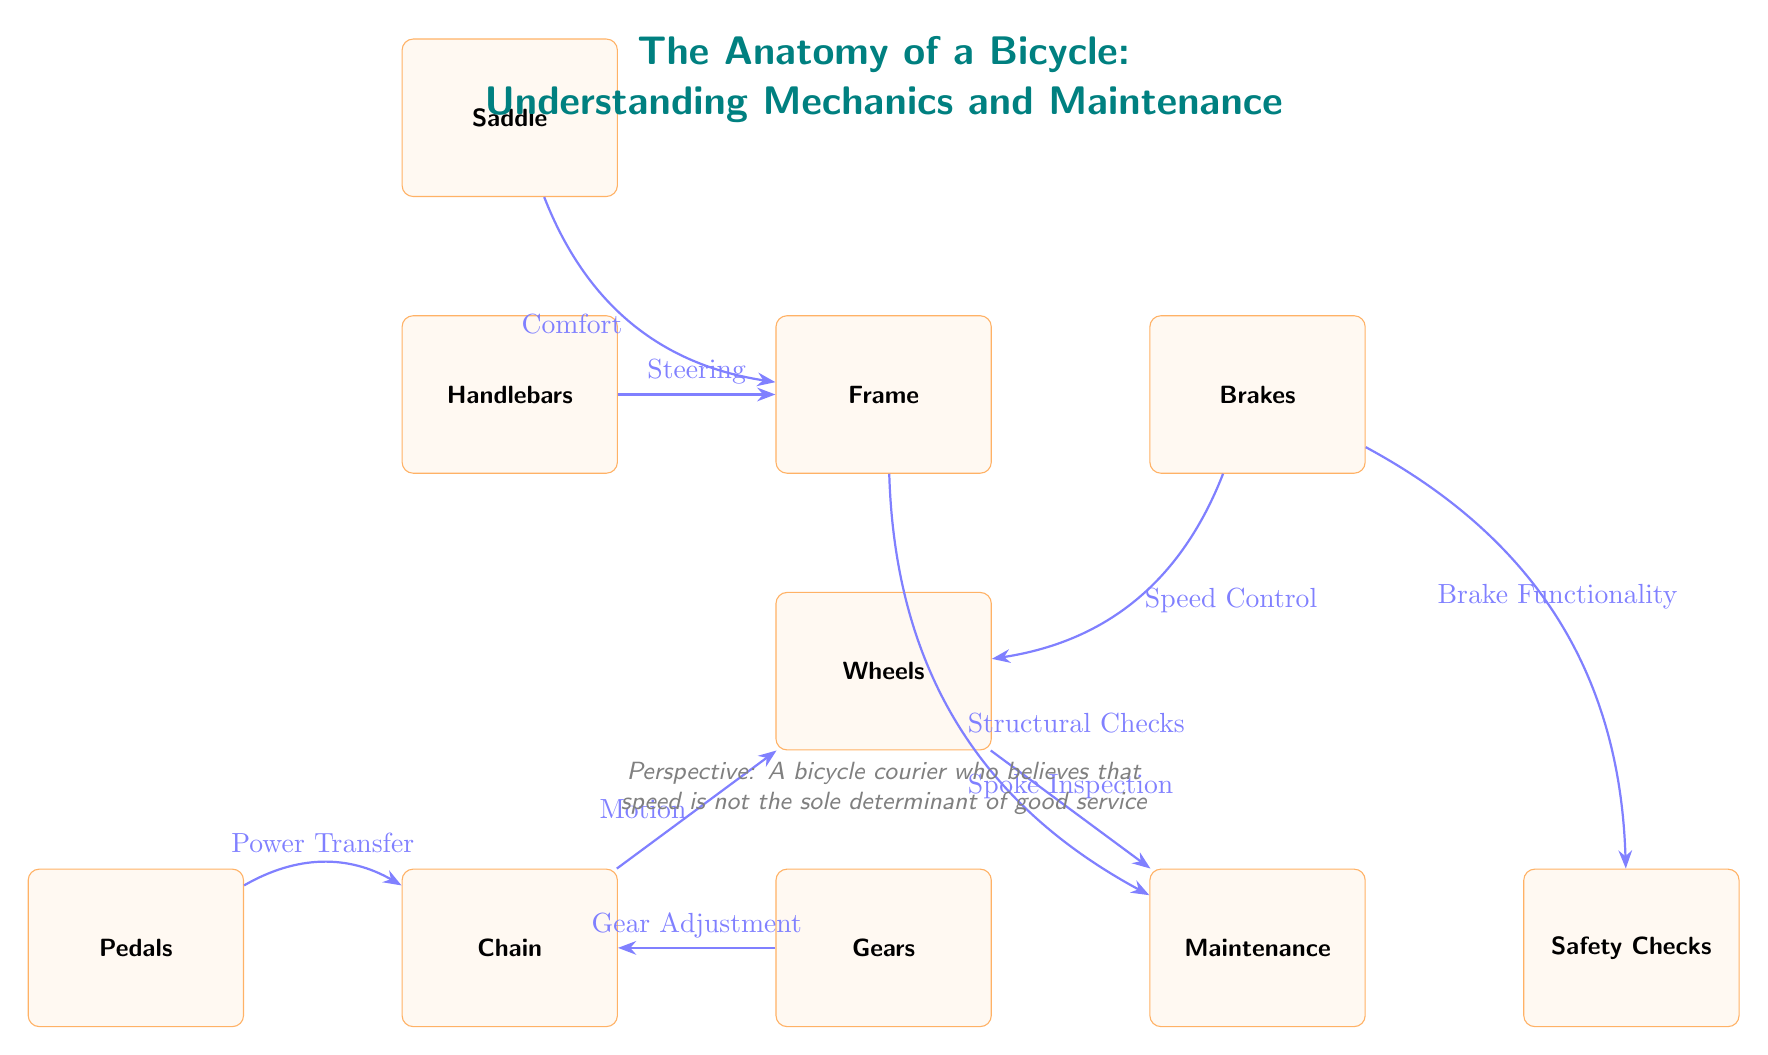What is the main structure of a bicycle? The main structure of a bicycle is represented by the node labeled "Frame." This node is centrally located and connects to other parts, indicating it is the foundational element of the bicycle's anatomy.
Answer: Frame How many components are directly connected to the frame? The frame node is connected to four components: handlebars, brakes, saddle, and maintenance. Thus, by counting the connections, we find that there are four direct components linked to the frame.
Answer: Four What is the function of the chain in a bicycle? The chain connects the pedals and wheels, serving the function of motion transfer from the power generated by the pedals to the rotation of the wheels. This illustrates its critical role in the drivetrain of the bicycle.
Answer: Motion What is the relationship between the brakes and the wheels? The diagram indicates that brakes provide speed control to the wheels. This means when the brakes are applied, they affect the movement and speed of the wheels directly.
Answer: Speed Control Which component is responsible for comfort in riding? According to the diagram, the component that contributes to comfort in riding is the saddle, which connects to the frame and is highlighted as a key part of the bicycle's anatomy for rider comfort.
Answer: Saddle How does gear adjustment relate to the chain? The gears adjust the tension and speed capability of the chain. This relationship is crucial because gear changes affect how effectively the chain transfers power to the wheels, which can influence overall cycling performance.
Answer: Gear Adjustment What action is indicated by the spokes of the wheels? The diagram shows that spokes are subject to inspection, implying that their maintenance is necessary to ensure the structural integrity and safety of the wheels during cycling.
Answer: Spoke Inspection What type of checks are necessary for the frame? The diagram emphasizes that structural checks are necessary for the frame. This is important to ensure that the frame remains safe and functional over time, preventing potential failures.
Answer: Structural Checks Which part of the bicycle helps in steering? The handlebars are identified in the diagram as the component that provides steering control. This underscores their vital role in navigating and maneuvering the bicycle effectively.
Answer: Handlebars 